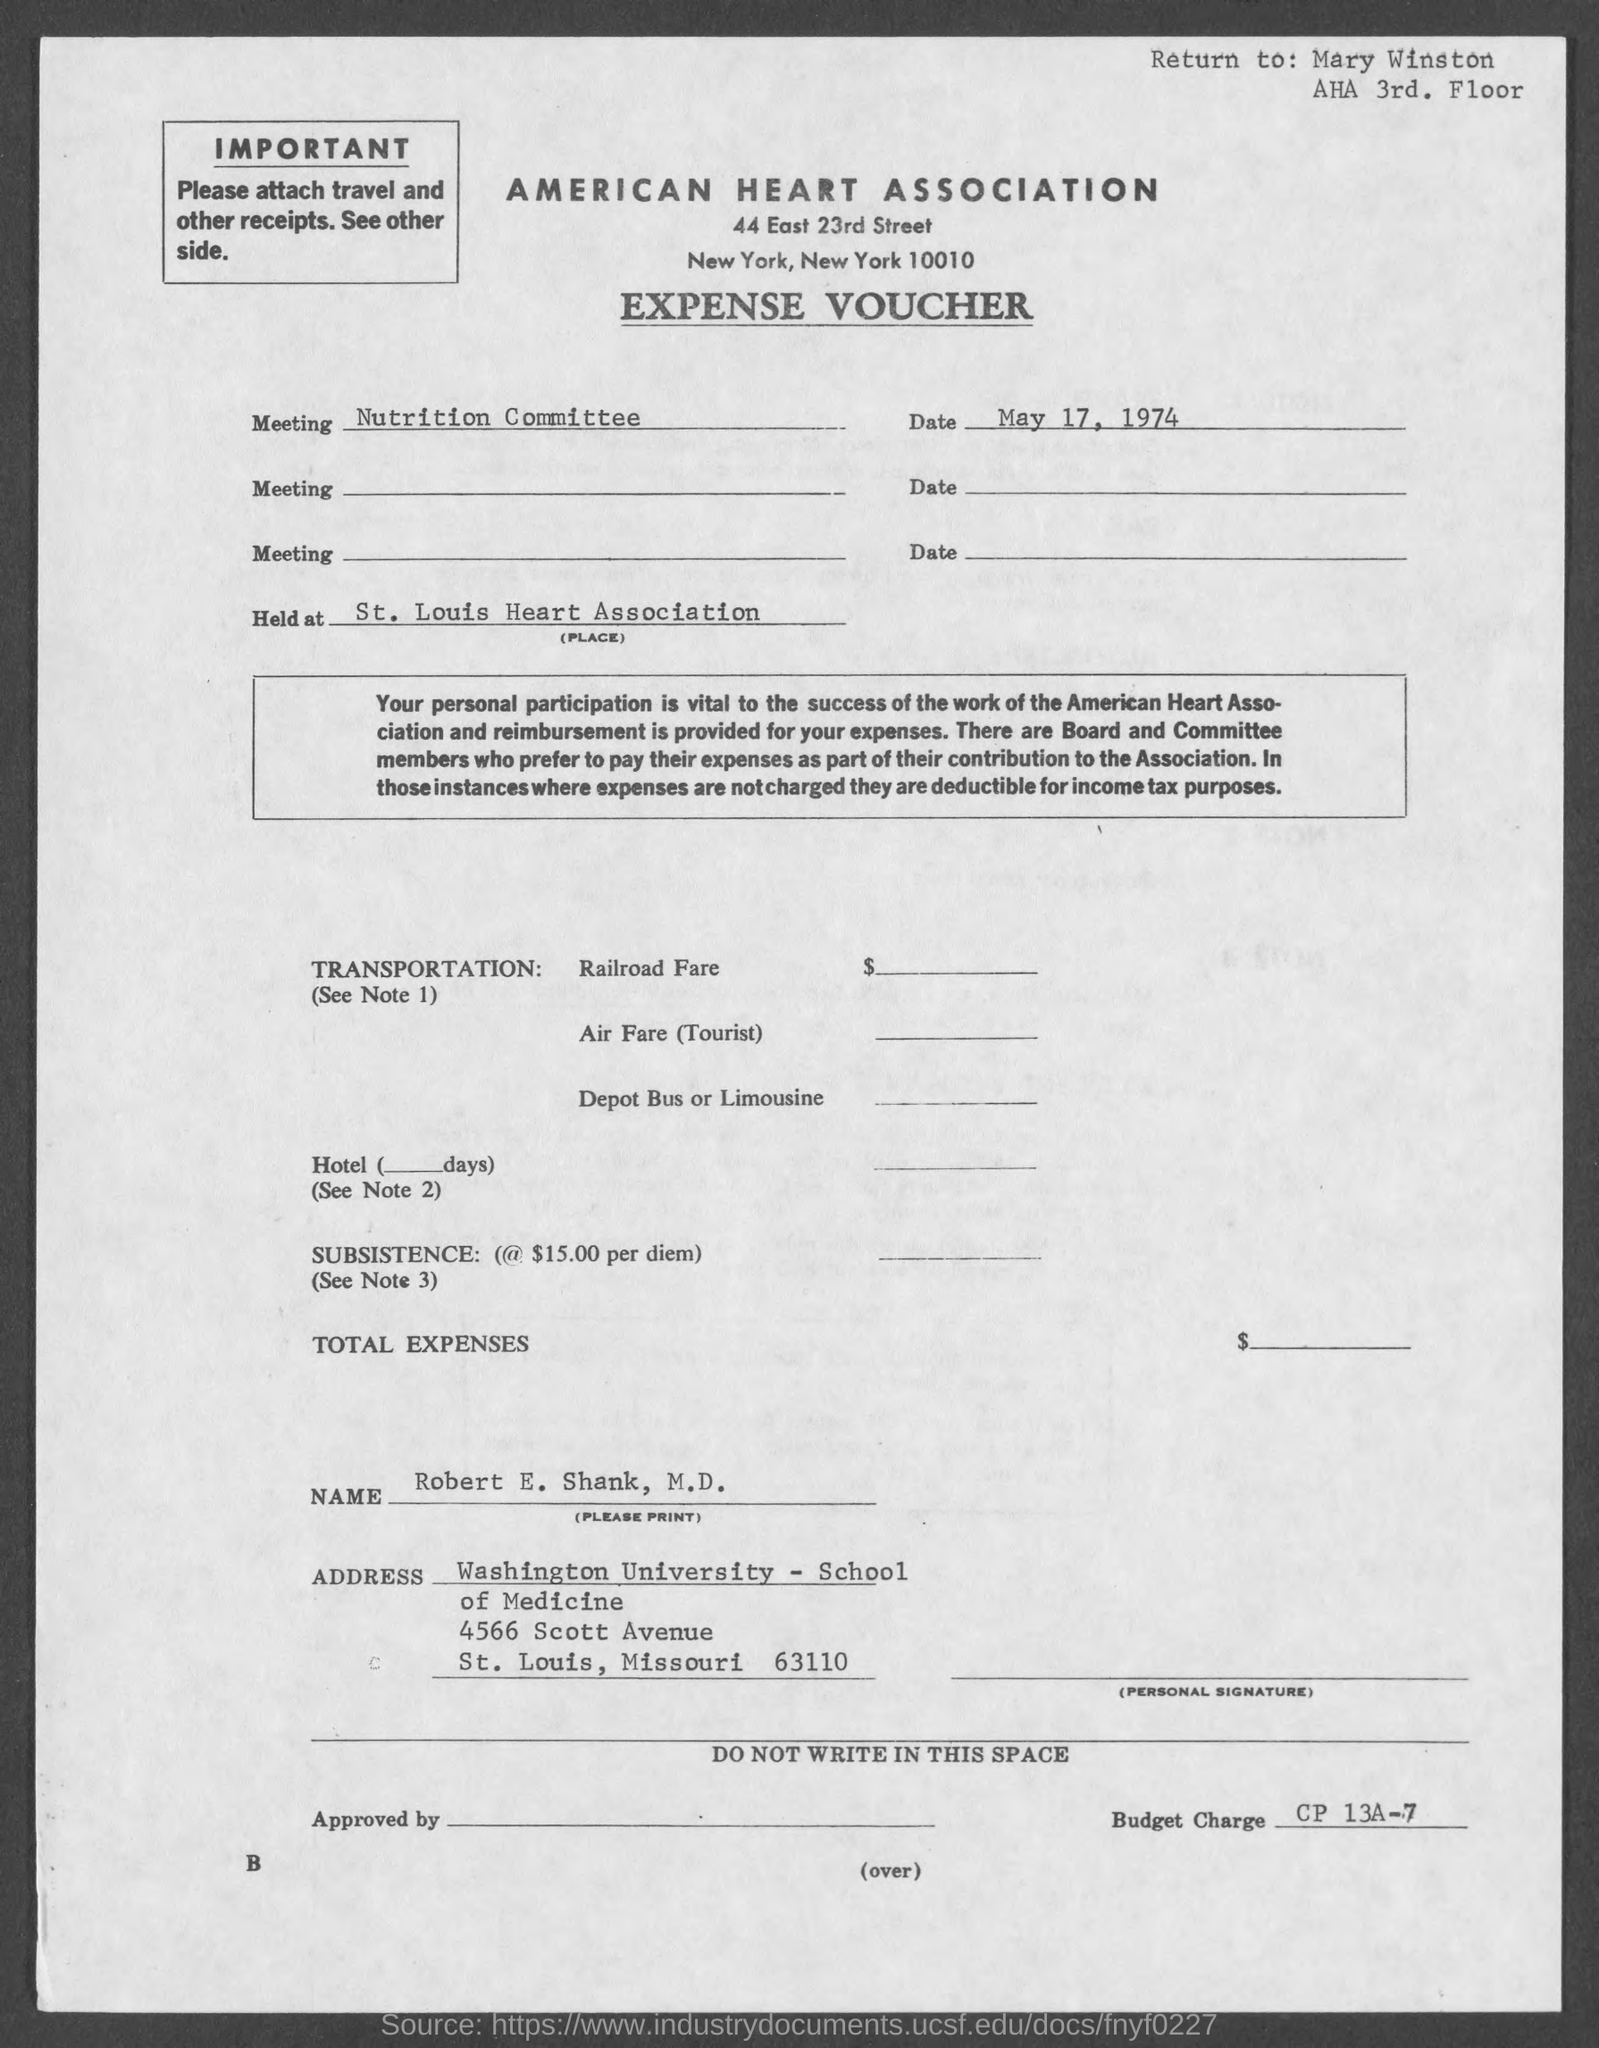What is the street address of american heart association ?
Keep it short and to the point. 44 east 23rd street. When is the expense voucher dated ?
Ensure brevity in your answer.  May 17, 1974. 